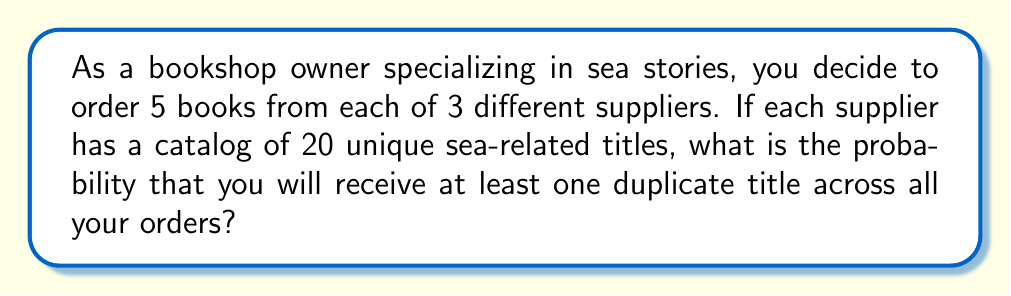Could you help me with this problem? Let's approach this step-by-step:

1) First, we need to calculate the probability of not getting any duplicates. Then we can subtract this from 1 to get the probability of at least one duplicate.

2) The total number of ways to select the books without duplicates can be calculated using the multiplication principle:

   $$\binom{20}{5} \cdot \binom{20}{5} \cdot \binom{20}{5}$$

   This represents choosing 5 books from 20 for the first supplier, then 5 from 20 for the second, and 5 from 20 for the third.

3) The total number of ways to select the books, including possible duplicates, is:

   $$20^5 \cdot 20^5 \cdot 20^5 = 20^{15}$$

   This represents choosing any 5 books from 20 for each supplier, allowing repetitions.

4) The probability of no duplicates is thus:

   $$P(\text{no duplicates}) = \frac{\binom{20}{5} \cdot \binom{20}{5} \cdot \binom{20}{5}}{20^{15}}$$

5) We can calculate this:

   $$\binom{20}{5} = 15504$$

   $$P(\text{no duplicates}) = \frac{15504^3}{20^{15}} \approx 0.0688$$

6) Therefore, the probability of at least one duplicate is:

   $$P(\text{at least one duplicate}) = 1 - P(\text{no duplicates}) \approx 1 - 0.0688 = 0.9312$$
Answer: $0.9312$ or $93.12\%$ 